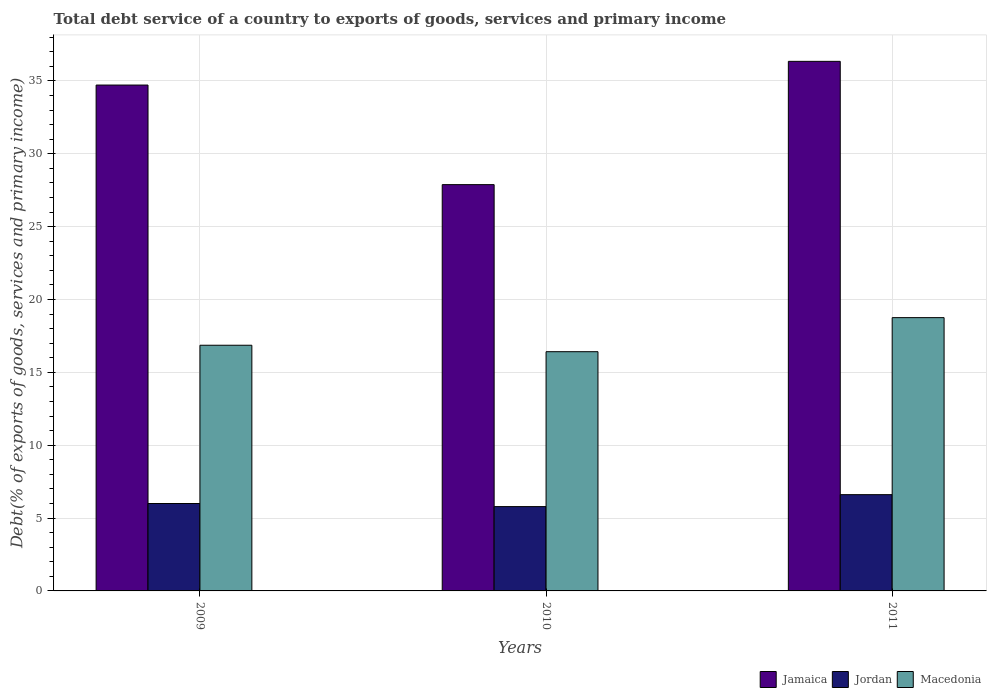How many bars are there on the 1st tick from the right?
Give a very brief answer. 3. What is the label of the 1st group of bars from the left?
Ensure brevity in your answer.  2009. What is the total debt service in Jamaica in 2009?
Provide a succinct answer. 34.72. Across all years, what is the maximum total debt service in Jamaica?
Keep it short and to the point. 36.34. Across all years, what is the minimum total debt service in Macedonia?
Your response must be concise. 16.42. In which year was the total debt service in Jordan maximum?
Give a very brief answer. 2011. In which year was the total debt service in Macedonia minimum?
Keep it short and to the point. 2010. What is the total total debt service in Jordan in the graph?
Provide a succinct answer. 18.39. What is the difference between the total debt service in Jordan in 2009 and that in 2011?
Give a very brief answer. -0.61. What is the difference between the total debt service in Macedonia in 2010 and the total debt service in Jordan in 2009?
Keep it short and to the point. 10.42. What is the average total debt service in Macedonia per year?
Keep it short and to the point. 17.34. In the year 2011, what is the difference between the total debt service in Macedonia and total debt service in Jordan?
Your answer should be compact. 12.15. In how many years, is the total debt service in Jamaica greater than 7 %?
Make the answer very short. 3. What is the ratio of the total debt service in Jamaica in 2010 to that in 2011?
Your response must be concise. 0.77. Is the difference between the total debt service in Macedonia in 2009 and 2011 greater than the difference between the total debt service in Jordan in 2009 and 2011?
Keep it short and to the point. No. What is the difference between the highest and the second highest total debt service in Macedonia?
Provide a short and direct response. 1.89. What is the difference between the highest and the lowest total debt service in Jordan?
Offer a terse response. 0.82. Is the sum of the total debt service in Macedonia in 2009 and 2010 greater than the maximum total debt service in Jordan across all years?
Give a very brief answer. Yes. What does the 3rd bar from the left in 2011 represents?
Ensure brevity in your answer.  Macedonia. What does the 2nd bar from the right in 2010 represents?
Make the answer very short. Jordan. How many bars are there?
Provide a succinct answer. 9. Are all the bars in the graph horizontal?
Give a very brief answer. No. Are the values on the major ticks of Y-axis written in scientific E-notation?
Offer a terse response. No. Where does the legend appear in the graph?
Provide a short and direct response. Bottom right. How are the legend labels stacked?
Provide a short and direct response. Horizontal. What is the title of the graph?
Provide a short and direct response. Total debt service of a country to exports of goods, services and primary income. Does "South Sudan" appear as one of the legend labels in the graph?
Give a very brief answer. No. What is the label or title of the Y-axis?
Give a very brief answer. Debt(% of exports of goods, services and primary income). What is the Debt(% of exports of goods, services and primary income) of Jamaica in 2009?
Keep it short and to the point. 34.72. What is the Debt(% of exports of goods, services and primary income) in Jordan in 2009?
Ensure brevity in your answer.  6. What is the Debt(% of exports of goods, services and primary income) of Macedonia in 2009?
Provide a short and direct response. 16.86. What is the Debt(% of exports of goods, services and primary income) in Jamaica in 2010?
Your response must be concise. 27.88. What is the Debt(% of exports of goods, services and primary income) in Jordan in 2010?
Make the answer very short. 5.79. What is the Debt(% of exports of goods, services and primary income) of Macedonia in 2010?
Make the answer very short. 16.42. What is the Debt(% of exports of goods, services and primary income) in Jamaica in 2011?
Keep it short and to the point. 36.34. What is the Debt(% of exports of goods, services and primary income) of Jordan in 2011?
Your answer should be very brief. 6.61. What is the Debt(% of exports of goods, services and primary income) in Macedonia in 2011?
Offer a very short reply. 18.75. Across all years, what is the maximum Debt(% of exports of goods, services and primary income) of Jamaica?
Provide a short and direct response. 36.34. Across all years, what is the maximum Debt(% of exports of goods, services and primary income) of Jordan?
Your answer should be very brief. 6.61. Across all years, what is the maximum Debt(% of exports of goods, services and primary income) of Macedonia?
Provide a short and direct response. 18.75. Across all years, what is the minimum Debt(% of exports of goods, services and primary income) of Jamaica?
Your answer should be very brief. 27.88. Across all years, what is the minimum Debt(% of exports of goods, services and primary income) in Jordan?
Ensure brevity in your answer.  5.79. Across all years, what is the minimum Debt(% of exports of goods, services and primary income) in Macedonia?
Keep it short and to the point. 16.42. What is the total Debt(% of exports of goods, services and primary income) of Jamaica in the graph?
Your answer should be compact. 98.94. What is the total Debt(% of exports of goods, services and primary income) of Jordan in the graph?
Your answer should be compact. 18.39. What is the total Debt(% of exports of goods, services and primary income) of Macedonia in the graph?
Make the answer very short. 52.03. What is the difference between the Debt(% of exports of goods, services and primary income) in Jamaica in 2009 and that in 2010?
Offer a terse response. 6.83. What is the difference between the Debt(% of exports of goods, services and primary income) in Jordan in 2009 and that in 2010?
Your response must be concise. 0.21. What is the difference between the Debt(% of exports of goods, services and primary income) in Macedonia in 2009 and that in 2010?
Give a very brief answer. 0.44. What is the difference between the Debt(% of exports of goods, services and primary income) of Jamaica in 2009 and that in 2011?
Ensure brevity in your answer.  -1.63. What is the difference between the Debt(% of exports of goods, services and primary income) in Jordan in 2009 and that in 2011?
Keep it short and to the point. -0.61. What is the difference between the Debt(% of exports of goods, services and primary income) in Macedonia in 2009 and that in 2011?
Give a very brief answer. -1.9. What is the difference between the Debt(% of exports of goods, services and primary income) in Jamaica in 2010 and that in 2011?
Provide a short and direct response. -8.46. What is the difference between the Debt(% of exports of goods, services and primary income) of Jordan in 2010 and that in 2011?
Provide a succinct answer. -0.82. What is the difference between the Debt(% of exports of goods, services and primary income) of Macedonia in 2010 and that in 2011?
Give a very brief answer. -2.34. What is the difference between the Debt(% of exports of goods, services and primary income) in Jamaica in 2009 and the Debt(% of exports of goods, services and primary income) in Jordan in 2010?
Make the answer very short. 28.93. What is the difference between the Debt(% of exports of goods, services and primary income) in Jamaica in 2009 and the Debt(% of exports of goods, services and primary income) in Macedonia in 2010?
Your answer should be compact. 18.3. What is the difference between the Debt(% of exports of goods, services and primary income) of Jordan in 2009 and the Debt(% of exports of goods, services and primary income) of Macedonia in 2010?
Provide a succinct answer. -10.42. What is the difference between the Debt(% of exports of goods, services and primary income) in Jamaica in 2009 and the Debt(% of exports of goods, services and primary income) in Jordan in 2011?
Provide a succinct answer. 28.11. What is the difference between the Debt(% of exports of goods, services and primary income) of Jamaica in 2009 and the Debt(% of exports of goods, services and primary income) of Macedonia in 2011?
Provide a short and direct response. 15.96. What is the difference between the Debt(% of exports of goods, services and primary income) in Jordan in 2009 and the Debt(% of exports of goods, services and primary income) in Macedonia in 2011?
Your answer should be very brief. -12.76. What is the difference between the Debt(% of exports of goods, services and primary income) in Jamaica in 2010 and the Debt(% of exports of goods, services and primary income) in Jordan in 2011?
Your response must be concise. 21.27. What is the difference between the Debt(% of exports of goods, services and primary income) in Jamaica in 2010 and the Debt(% of exports of goods, services and primary income) in Macedonia in 2011?
Provide a short and direct response. 9.13. What is the difference between the Debt(% of exports of goods, services and primary income) of Jordan in 2010 and the Debt(% of exports of goods, services and primary income) of Macedonia in 2011?
Provide a succinct answer. -12.97. What is the average Debt(% of exports of goods, services and primary income) in Jamaica per year?
Offer a terse response. 32.98. What is the average Debt(% of exports of goods, services and primary income) of Jordan per year?
Keep it short and to the point. 6.13. What is the average Debt(% of exports of goods, services and primary income) in Macedonia per year?
Your answer should be compact. 17.34. In the year 2009, what is the difference between the Debt(% of exports of goods, services and primary income) in Jamaica and Debt(% of exports of goods, services and primary income) in Jordan?
Ensure brevity in your answer.  28.72. In the year 2009, what is the difference between the Debt(% of exports of goods, services and primary income) in Jamaica and Debt(% of exports of goods, services and primary income) in Macedonia?
Your response must be concise. 17.86. In the year 2009, what is the difference between the Debt(% of exports of goods, services and primary income) in Jordan and Debt(% of exports of goods, services and primary income) in Macedonia?
Your answer should be very brief. -10.86. In the year 2010, what is the difference between the Debt(% of exports of goods, services and primary income) of Jamaica and Debt(% of exports of goods, services and primary income) of Jordan?
Offer a terse response. 22.09. In the year 2010, what is the difference between the Debt(% of exports of goods, services and primary income) in Jamaica and Debt(% of exports of goods, services and primary income) in Macedonia?
Your answer should be compact. 11.47. In the year 2010, what is the difference between the Debt(% of exports of goods, services and primary income) of Jordan and Debt(% of exports of goods, services and primary income) of Macedonia?
Provide a short and direct response. -10.63. In the year 2011, what is the difference between the Debt(% of exports of goods, services and primary income) in Jamaica and Debt(% of exports of goods, services and primary income) in Jordan?
Provide a short and direct response. 29.74. In the year 2011, what is the difference between the Debt(% of exports of goods, services and primary income) in Jamaica and Debt(% of exports of goods, services and primary income) in Macedonia?
Offer a very short reply. 17.59. In the year 2011, what is the difference between the Debt(% of exports of goods, services and primary income) of Jordan and Debt(% of exports of goods, services and primary income) of Macedonia?
Provide a short and direct response. -12.15. What is the ratio of the Debt(% of exports of goods, services and primary income) in Jamaica in 2009 to that in 2010?
Keep it short and to the point. 1.25. What is the ratio of the Debt(% of exports of goods, services and primary income) in Jordan in 2009 to that in 2010?
Make the answer very short. 1.04. What is the ratio of the Debt(% of exports of goods, services and primary income) of Macedonia in 2009 to that in 2010?
Your response must be concise. 1.03. What is the ratio of the Debt(% of exports of goods, services and primary income) of Jamaica in 2009 to that in 2011?
Keep it short and to the point. 0.96. What is the ratio of the Debt(% of exports of goods, services and primary income) of Jordan in 2009 to that in 2011?
Give a very brief answer. 0.91. What is the ratio of the Debt(% of exports of goods, services and primary income) of Macedonia in 2009 to that in 2011?
Give a very brief answer. 0.9. What is the ratio of the Debt(% of exports of goods, services and primary income) of Jamaica in 2010 to that in 2011?
Your answer should be compact. 0.77. What is the ratio of the Debt(% of exports of goods, services and primary income) of Jordan in 2010 to that in 2011?
Your answer should be very brief. 0.88. What is the ratio of the Debt(% of exports of goods, services and primary income) in Macedonia in 2010 to that in 2011?
Your answer should be very brief. 0.88. What is the difference between the highest and the second highest Debt(% of exports of goods, services and primary income) in Jamaica?
Your answer should be compact. 1.63. What is the difference between the highest and the second highest Debt(% of exports of goods, services and primary income) in Jordan?
Ensure brevity in your answer.  0.61. What is the difference between the highest and the second highest Debt(% of exports of goods, services and primary income) in Macedonia?
Offer a terse response. 1.9. What is the difference between the highest and the lowest Debt(% of exports of goods, services and primary income) in Jamaica?
Provide a succinct answer. 8.46. What is the difference between the highest and the lowest Debt(% of exports of goods, services and primary income) of Jordan?
Offer a terse response. 0.82. What is the difference between the highest and the lowest Debt(% of exports of goods, services and primary income) of Macedonia?
Provide a succinct answer. 2.34. 